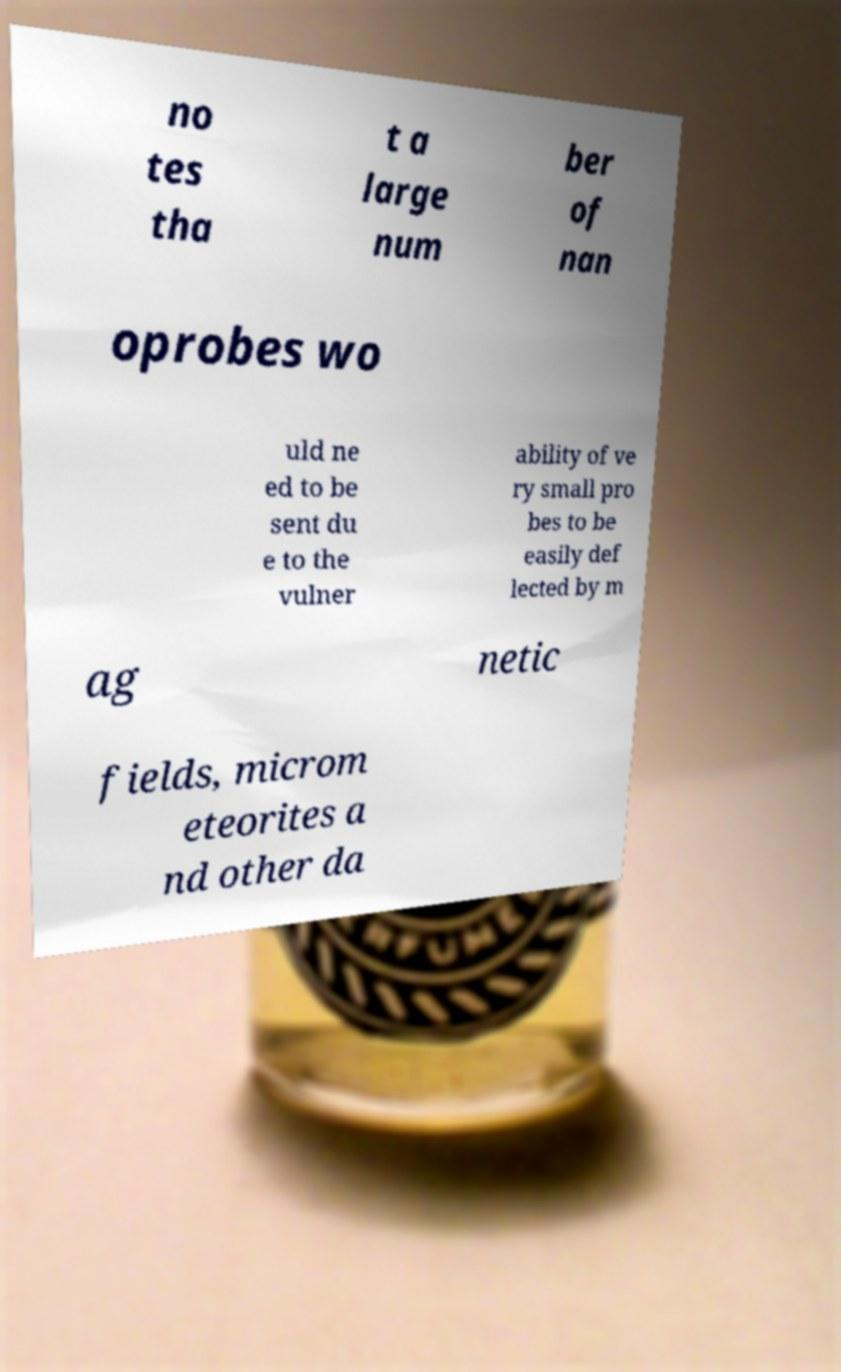Could you extract and type out the text from this image? no tes tha t a large num ber of nan oprobes wo uld ne ed to be sent du e to the vulner ability of ve ry small pro bes to be easily def lected by m ag netic fields, microm eteorites a nd other da 